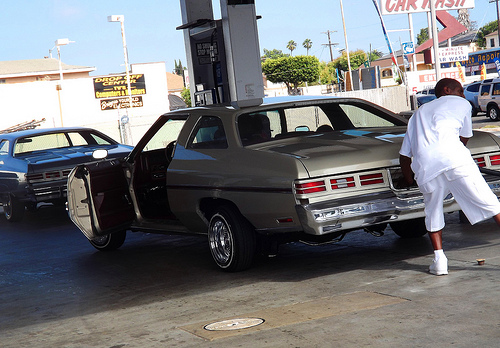<image>
Can you confirm if the tire is under the tail light? No. The tire is not positioned under the tail light. The vertical relationship between these objects is different. 